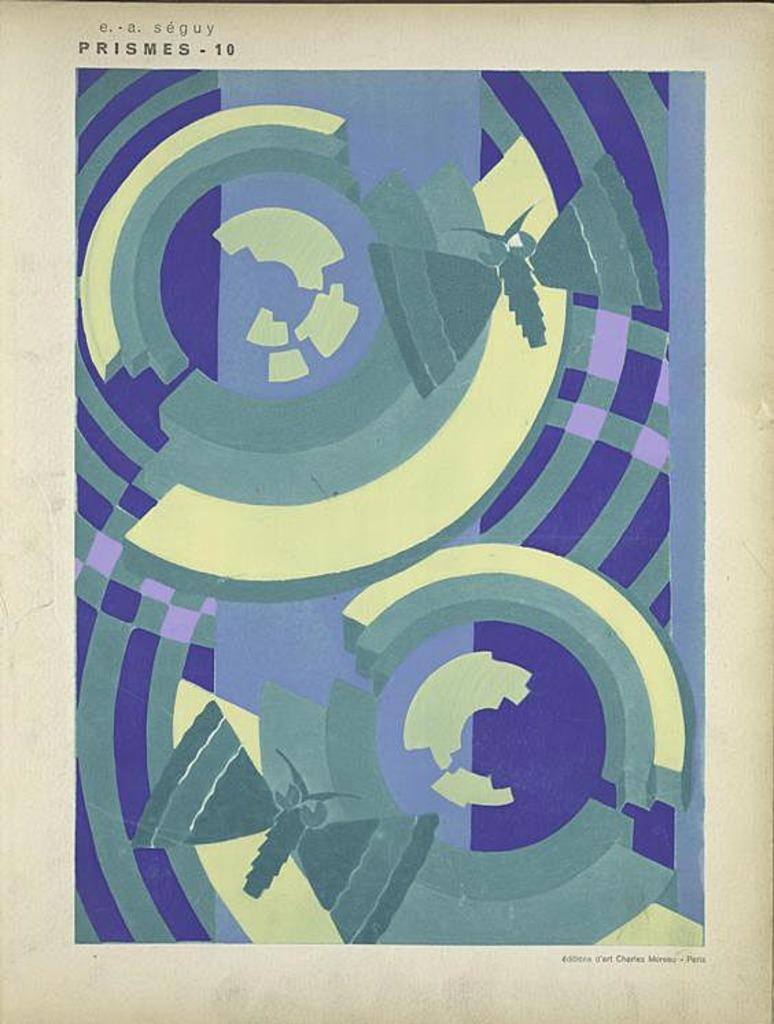What is the main subject of the image? There is a painting in the image. What colors are used in the painting? The painting has cream, green, blue, and purple colors. What is the color of the surface the painting is on? The painting is on a cream-colored surface. What can be seen at the top of the image? There are words written at the top of the image. How many bubbles are floating around the painting in the image? There are no bubbles present in the image; it features a painting with words at the top. What type of riddle is depicted in the painting? There is no riddle depicted in the painting; it is a visual artwork with specific colors and words at the top. 